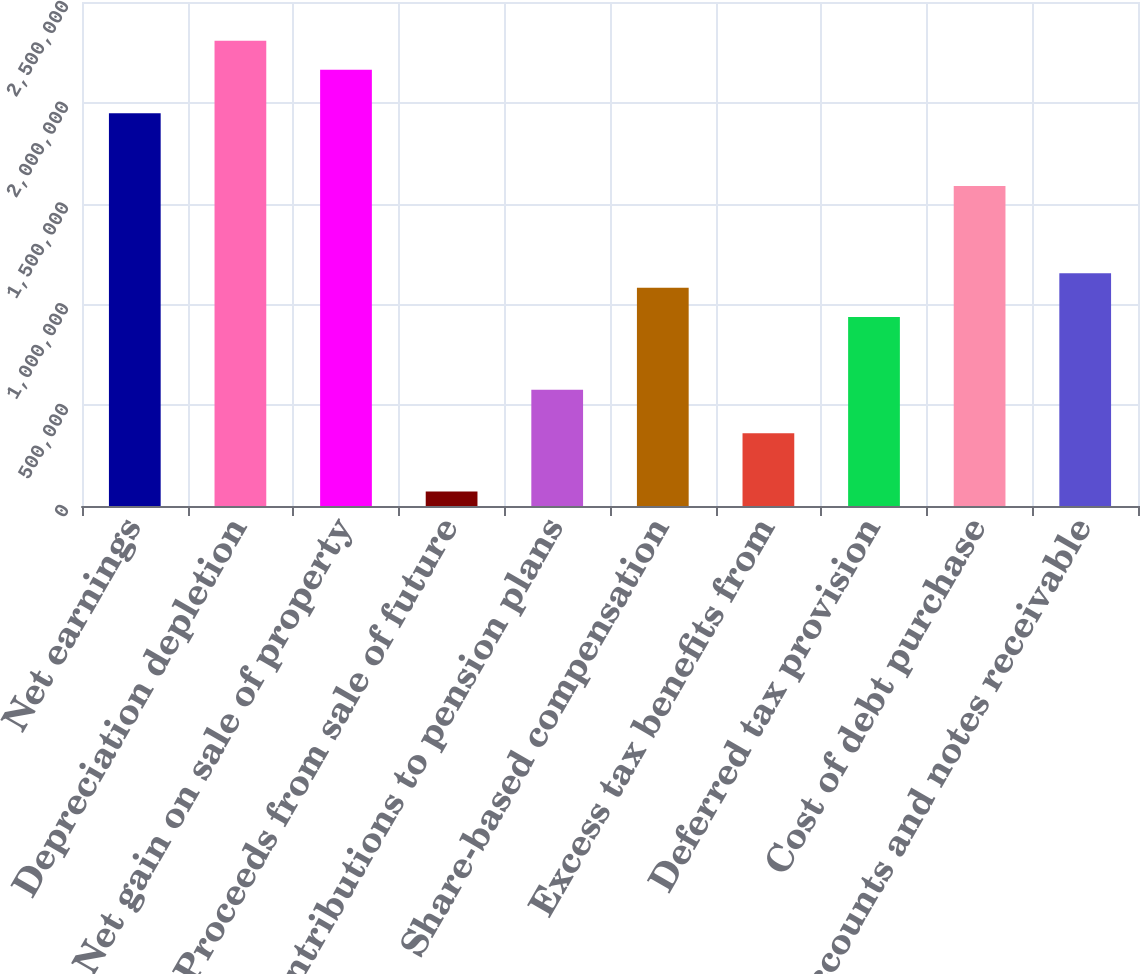Convert chart. <chart><loc_0><loc_0><loc_500><loc_500><bar_chart><fcel>Net earnings<fcel>Depreciation depletion<fcel>Net gain on sale of property<fcel>Proceeds from sale of future<fcel>Contributions to pension plans<fcel>Share-based compensation<fcel>Excess tax benefits from<fcel>Deferred tax provision<fcel>Cost of debt purchase<fcel>Accounts and notes receivable<nl><fcel>1.94767e+06<fcel>2.30835e+06<fcel>2.16408e+06<fcel>72136.7<fcel>577087<fcel>1.08204e+06<fcel>360680<fcel>937766<fcel>1.58699e+06<fcel>1.15417e+06<nl></chart> 